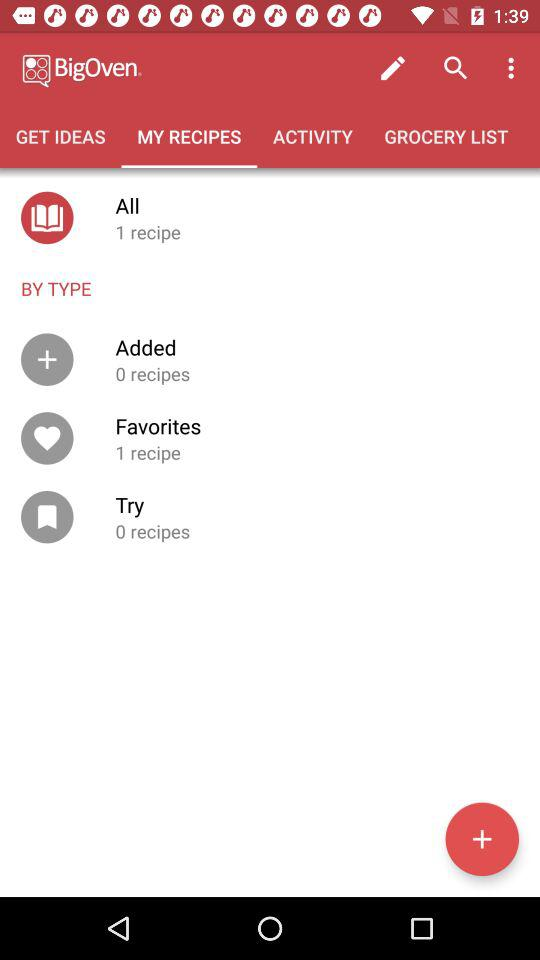How many more recipes are in my favorites than in my added recipes?
Answer the question using a single word or phrase. 1 